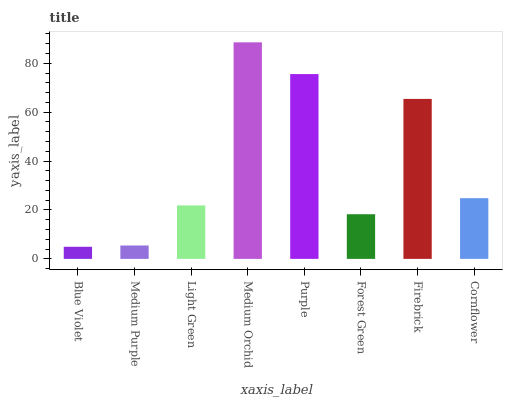Is Medium Purple the minimum?
Answer yes or no. No. Is Medium Purple the maximum?
Answer yes or no. No. Is Medium Purple greater than Blue Violet?
Answer yes or no. Yes. Is Blue Violet less than Medium Purple?
Answer yes or no. Yes. Is Blue Violet greater than Medium Purple?
Answer yes or no. No. Is Medium Purple less than Blue Violet?
Answer yes or no. No. Is Cornflower the high median?
Answer yes or no. Yes. Is Light Green the low median?
Answer yes or no. Yes. Is Forest Green the high median?
Answer yes or no. No. Is Blue Violet the low median?
Answer yes or no. No. 